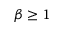Convert formula to latex. <formula><loc_0><loc_0><loc_500><loc_500>\beta \geq 1</formula> 